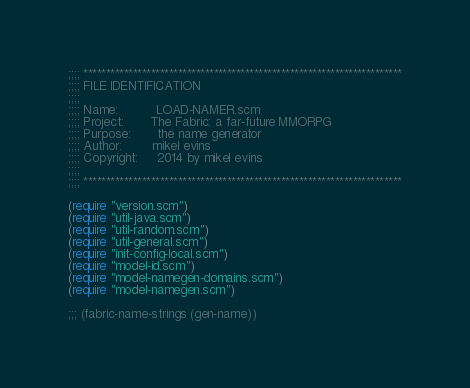Convert code to text. <code><loc_0><loc_0><loc_500><loc_500><_Scheme_>;;;; ***********************************************************************
;;;; FILE IDENTIFICATION
;;;;
;;;; Name:          LOAD-NAMER.scm
;;;; Project:       The Fabric: a far-future MMORPG
;;;; Purpose:       the name generator
;;;; Author:        mikel evins
;;;; Copyright:     2014 by mikel evins
;;;;
;;;; ***********************************************************************

(require "version.scm")
(require "util-java.scm")
(require "util-random.scm")
(require "util-general.scm")
(require "init-config-local.scm")
(require "model-id.scm")
(require "model-namegen-domains.scm")
(require "model-namegen.scm")

;;; (fabric-name-strings (gen-name))

</code> 